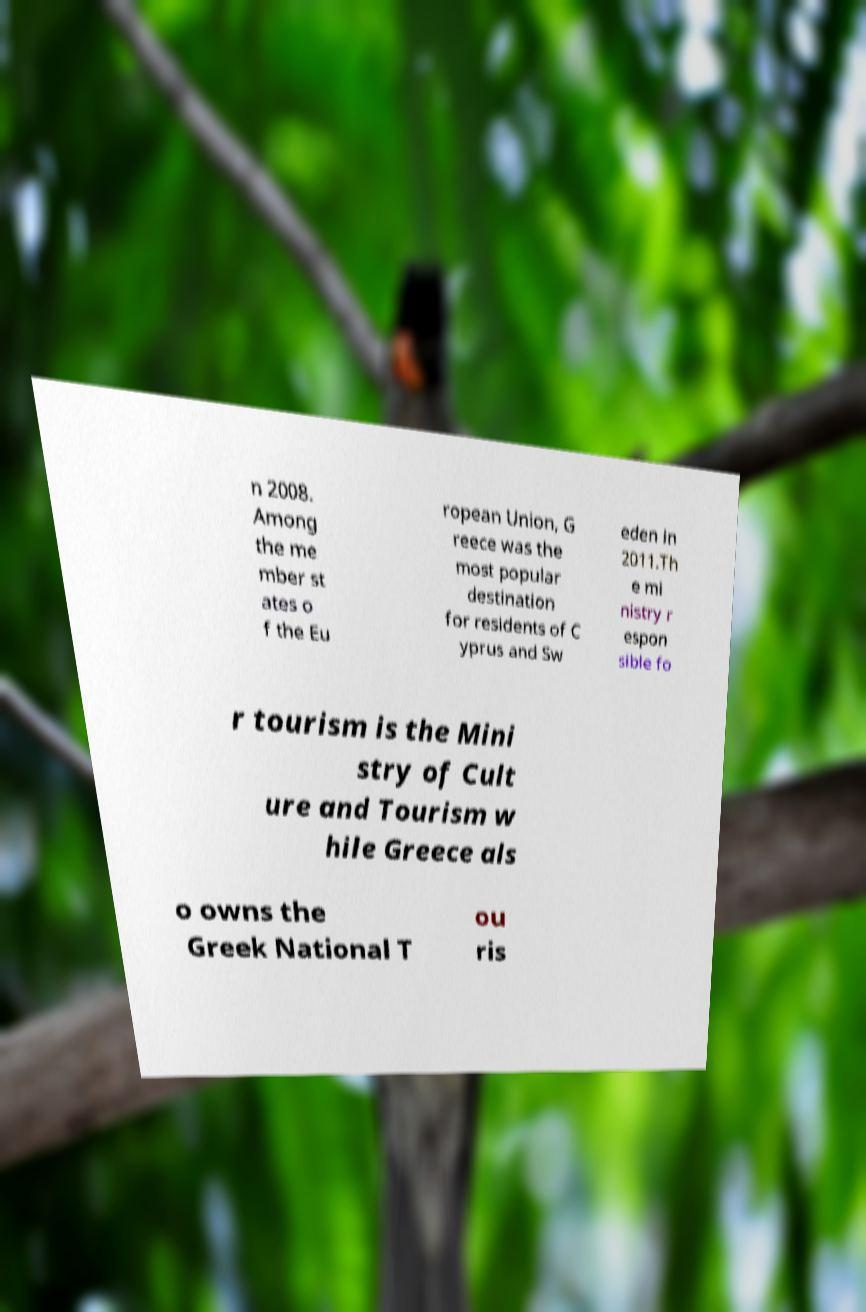There's text embedded in this image that I need extracted. Can you transcribe it verbatim? n 2008. Among the me mber st ates o f the Eu ropean Union, G reece was the most popular destination for residents of C yprus and Sw eden in 2011.Th e mi nistry r espon sible fo r tourism is the Mini stry of Cult ure and Tourism w hile Greece als o owns the Greek National T ou ris 